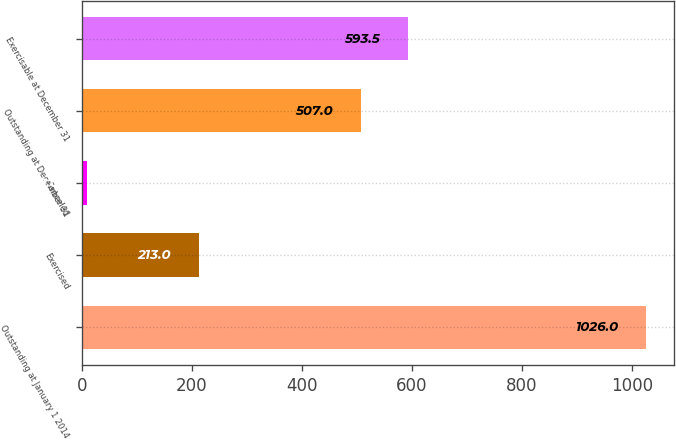Convert chart to OTSL. <chart><loc_0><loc_0><loc_500><loc_500><bar_chart><fcel>Outstanding at January 1 2014<fcel>Exercised<fcel>Canceled<fcel>Outstanding at December 31<fcel>Exercisable at December 31<nl><fcel>1026<fcel>213<fcel>10<fcel>507<fcel>593.5<nl></chart> 